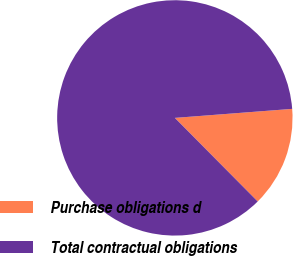<chart> <loc_0><loc_0><loc_500><loc_500><pie_chart><fcel>Purchase obligations d<fcel>Total contractual obligations<nl><fcel>13.79%<fcel>86.21%<nl></chart> 